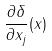<formula> <loc_0><loc_0><loc_500><loc_500>\frac { \partial \delta } { \partial x _ { j } } ( x )</formula> 